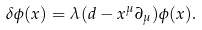<formula> <loc_0><loc_0><loc_500><loc_500>\delta \phi ( x ) = \lambda ( d - x ^ { \mu } \partial _ { \mu } ) \phi ( x ) .</formula> 